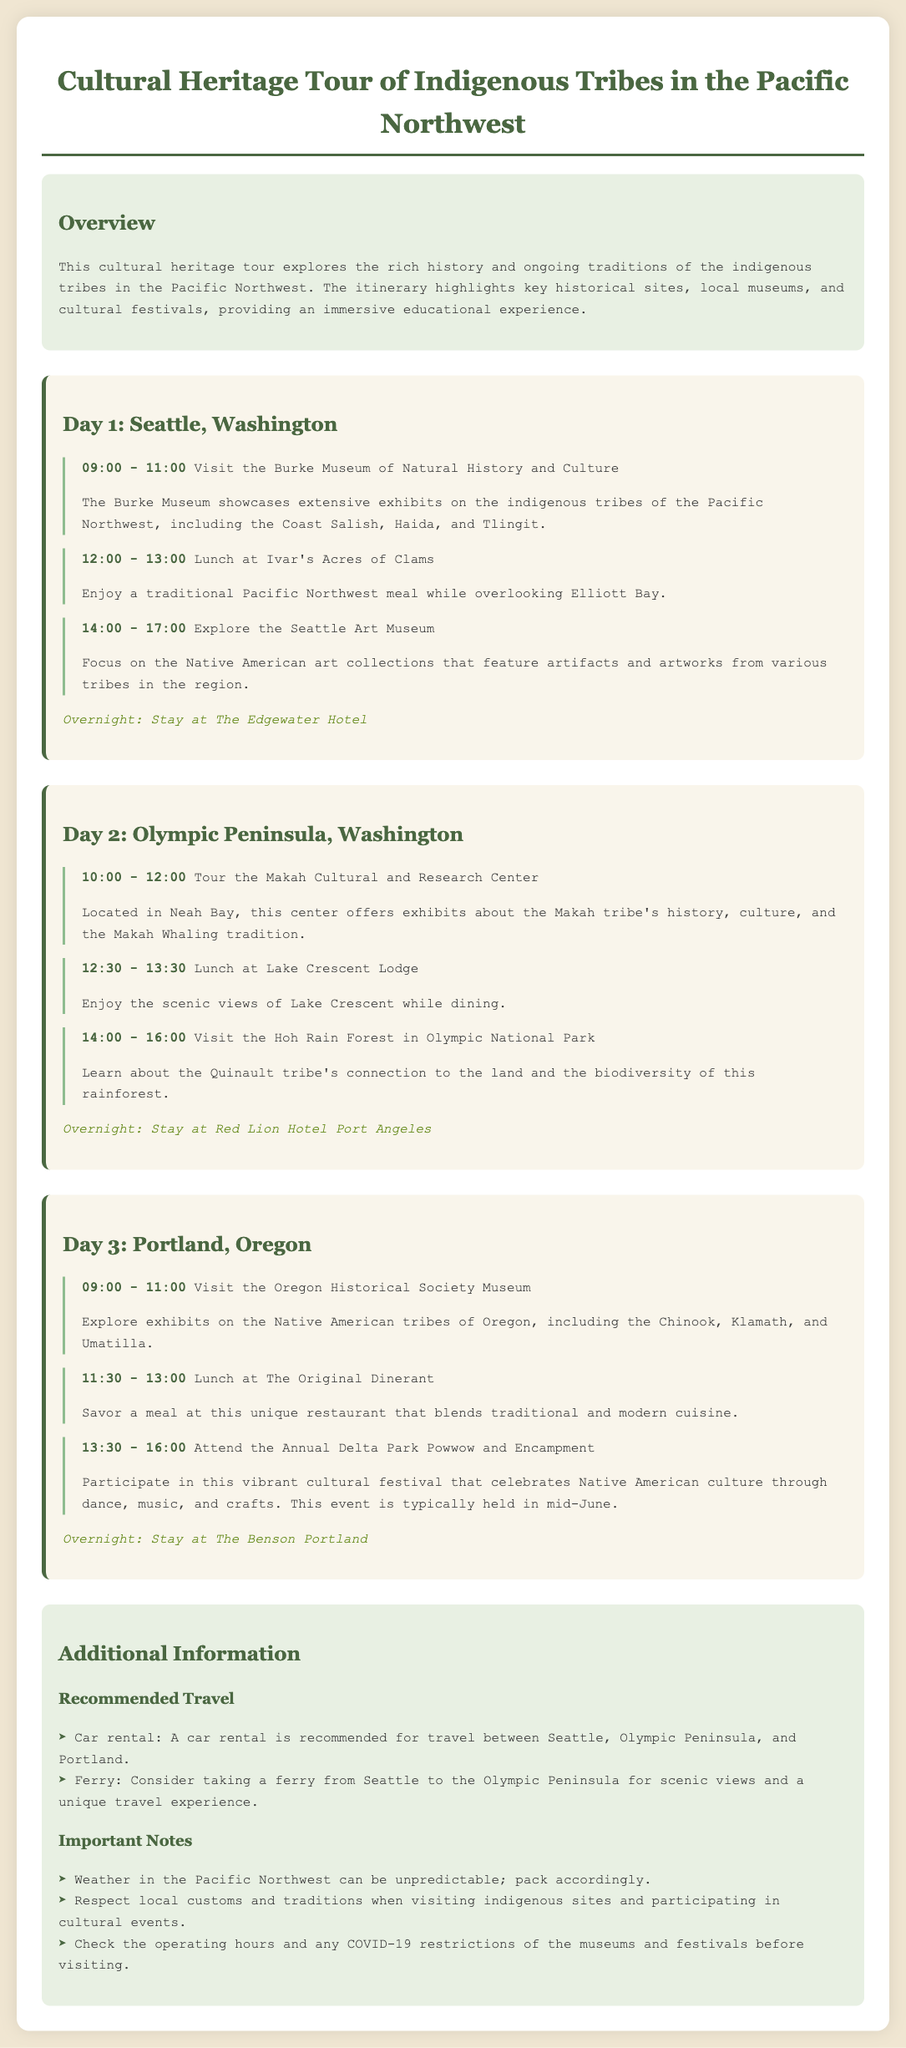What is the name of the first museum visited? The first museum listed in the itinerary is the Burke Museum of Natural History and Culture.
Answer: Burke Museum of Natural History and Culture What time does the tour of the Makah Cultural and Research Center start? The itinerary indicates that the tour starts at 10:00 AM on Day 2.
Answer: 10:00 Which hotel is mentioned for the overnight stay in Seattle? The document specifies that the overnight stay in Seattle is at The Edgewater Hotel.
Answer: The Edgewater Hotel What is the main focus of the Seattle Art Museum's exhibits? The Seattle Art Museum focuses on the Native American art collections that feature artworks from various tribes.
Answer: Native American art collections How long is the Annual Delta Park Powwow and Encampment scheduled to last? The event is listed in the itinerary from 1:30 PM to 4:00 PM, lasting 2.5 hours.
Answer: 2.5 hours What travel option is recommended for scenic views between Seattle and the Olympic Peninsula? The document suggests taking a ferry for scenic views as a travel option.
Answer: ferry What significant feature is highlighted about the Hoh Rain Forest? The itinerary highlights the connection of the Quinault tribe to the land and the biodiversity of the rainforest.
Answer: Quinault tribe's connection to the land What type of cuisine is offered at The Original Dinerant? The document describes the cuisine at The Original Dinerant as a blend of traditional and modern cuisine.
Answer: traditional and modern cuisine What is the weather characteristic mentioned for the Pacific Northwest? The document notes that the weather in the Pacific Northwest can be unpredictable.
Answer: unpredictable 